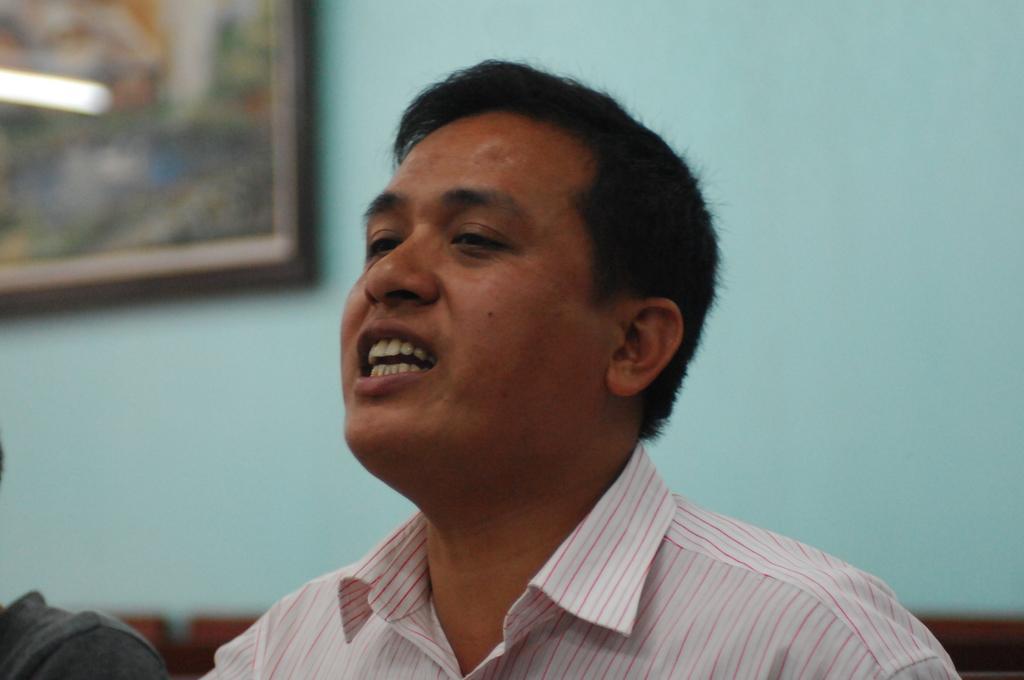Could you give a brief overview of what you see in this image? In the picture we can see a man talking something opening his mouth and behind him we can see a wall with a photo frame to it. 